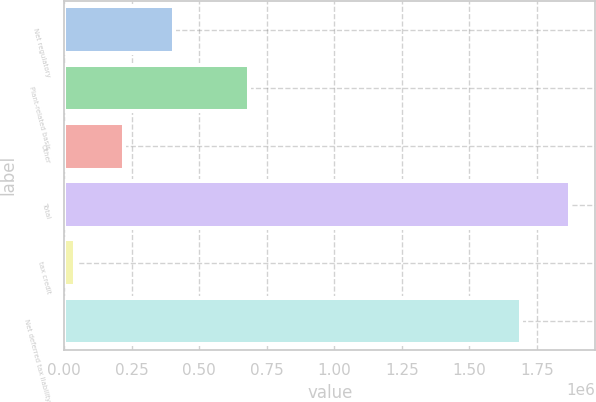Convert chart to OTSL. <chart><loc_0><loc_0><loc_500><loc_500><bar_chart><fcel>Net regulatory<fcel>Plant-related basis<fcel>Other<fcel>Total<fcel>tax credit<fcel>Net deferred tax liability<nl><fcel>404967<fcel>683590<fcel>222981<fcel>1.87316e+06<fcel>40995<fcel>1.69117e+06<nl></chart> 